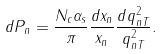Convert formula to latex. <formula><loc_0><loc_0><loc_500><loc_500>d P _ { n } = \frac { N _ { c } \alpha _ { s } } { \pi } \frac { d x _ { n } } { x _ { n } } \frac { d q _ { n T } ^ { 2 } } { q _ { n T } ^ { 2 } } .</formula> 